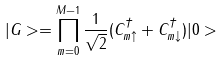Convert formula to latex. <formula><loc_0><loc_0><loc_500><loc_500>| G > = \prod ^ { M - 1 } _ { m = 0 } \frac { 1 } { \sqrt { 2 } } ( C ^ { \dagger } _ { m \uparrow } + C ^ { \dagger } _ { m \downarrow } ) | 0 ></formula> 